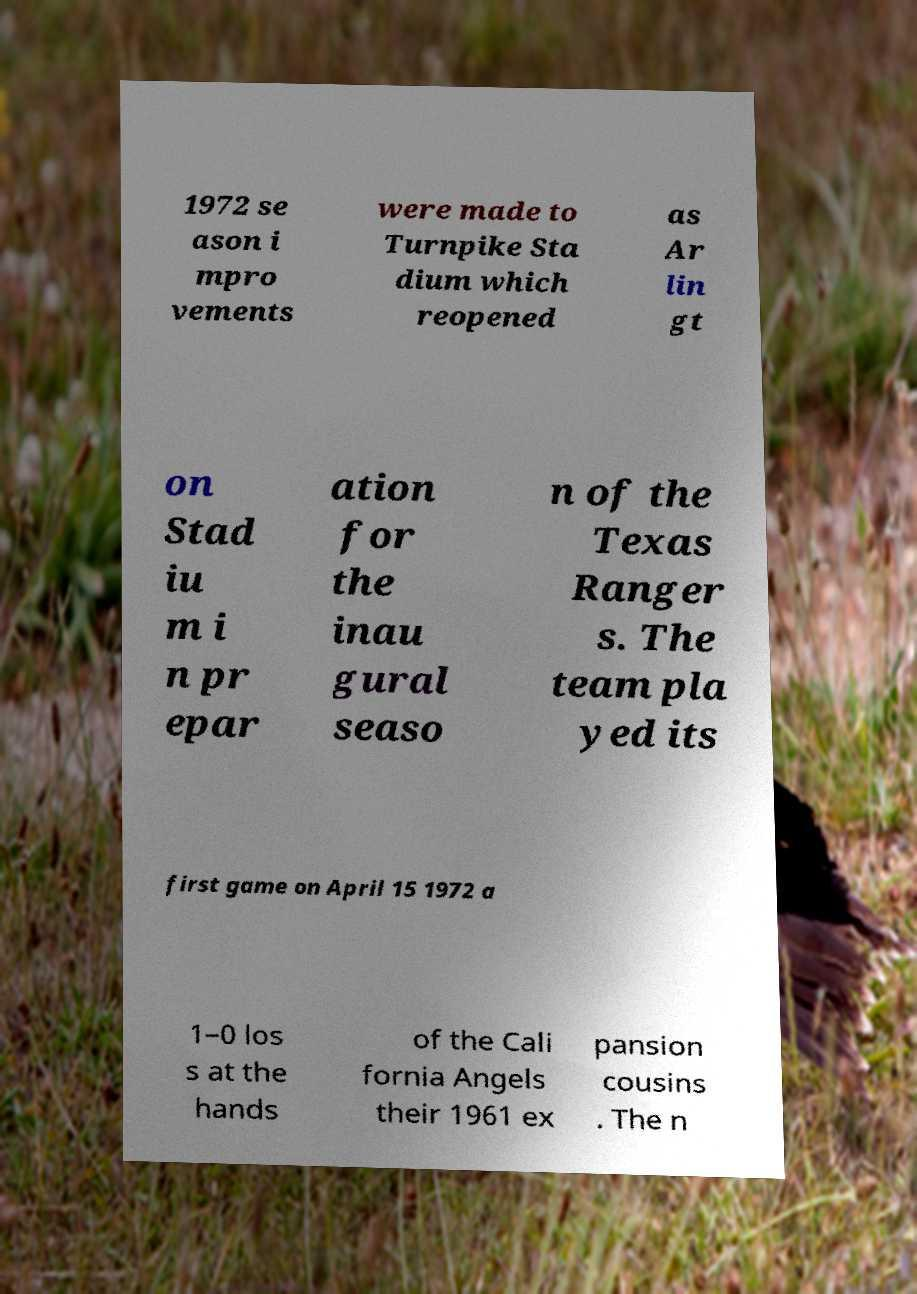For documentation purposes, I need the text within this image transcribed. Could you provide that? 1972 se ason i mpro vements were made to Turnpike Sta dium which reopened as Ar lin gt on Stad iu m i n pr epar ation for the inau gural seaso n of the Texas Ranger s. The team pla yed its first game on April 15 1972 a 1–0 los s at the hands of the Cali fornia Angels their 1961 ex pansion cousins . The n 